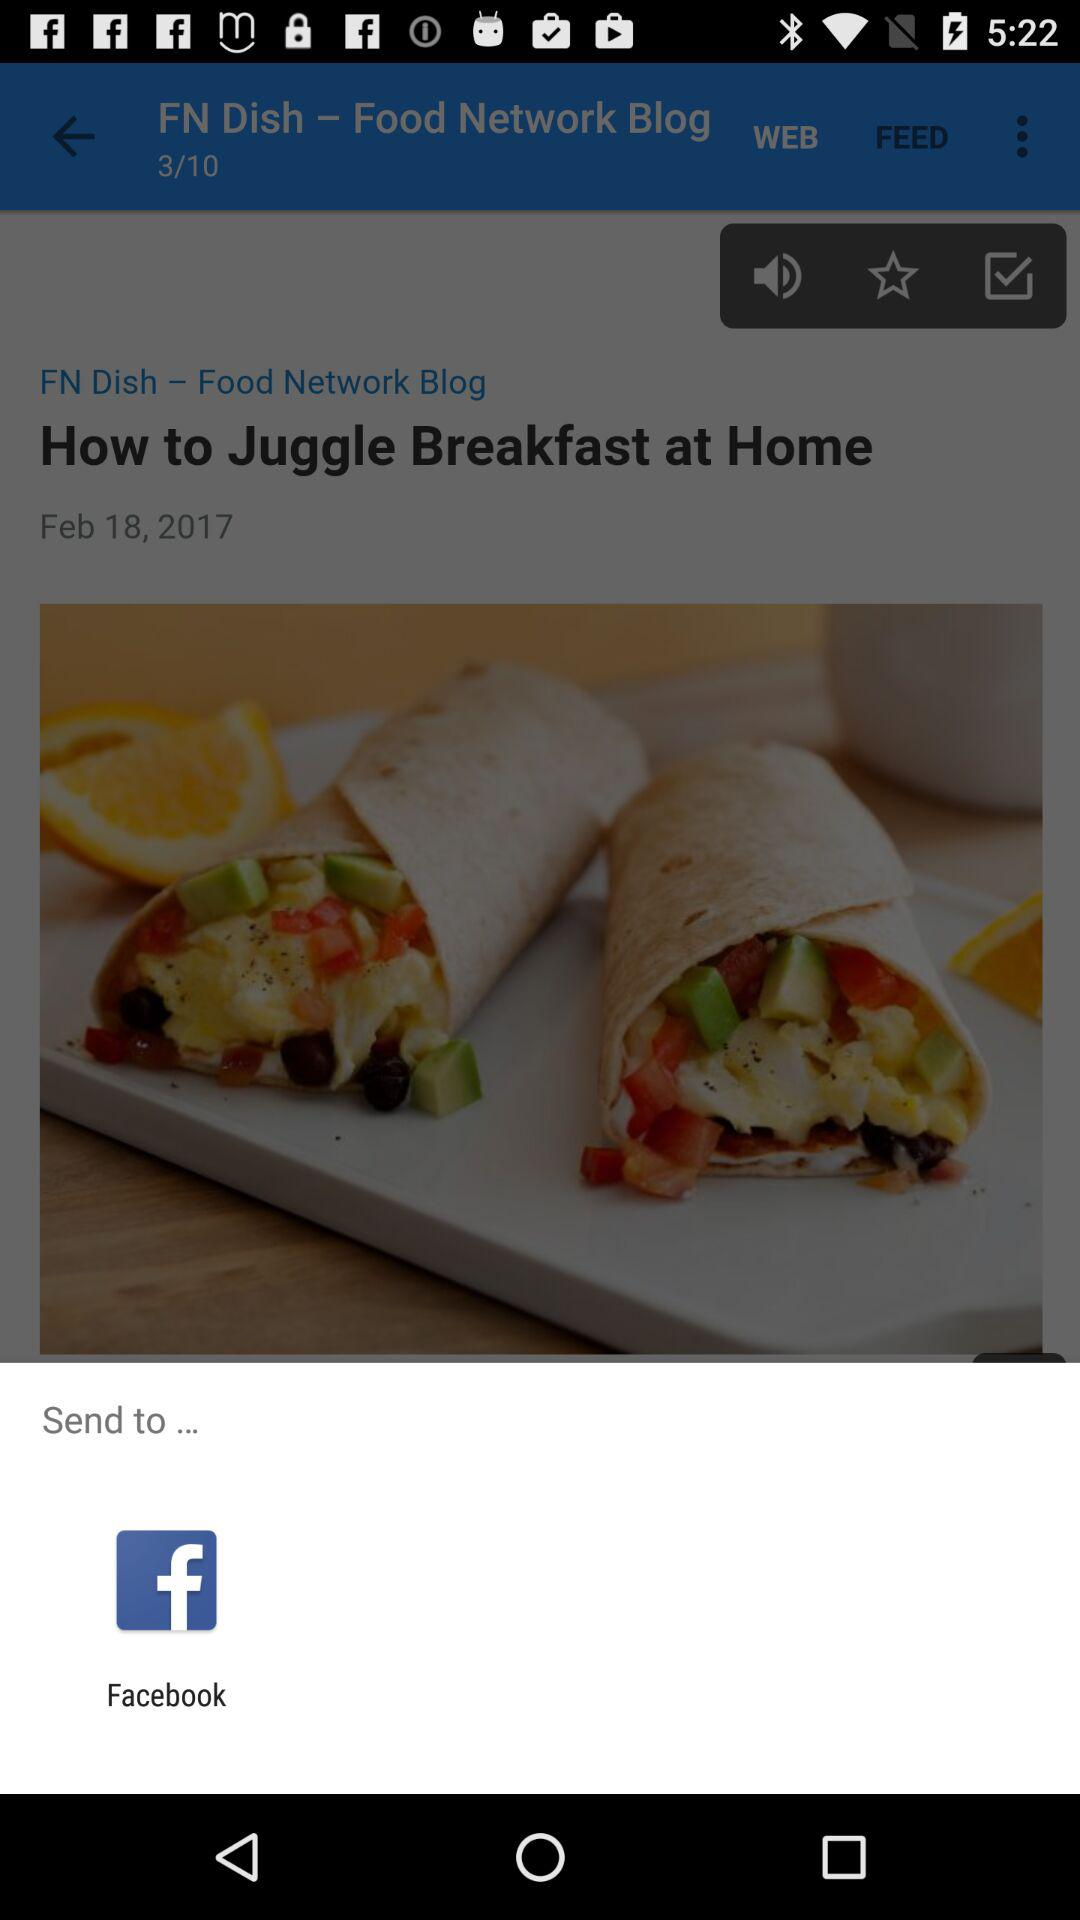What is the option for sending the content? The option for sending the content is "Facebook". 